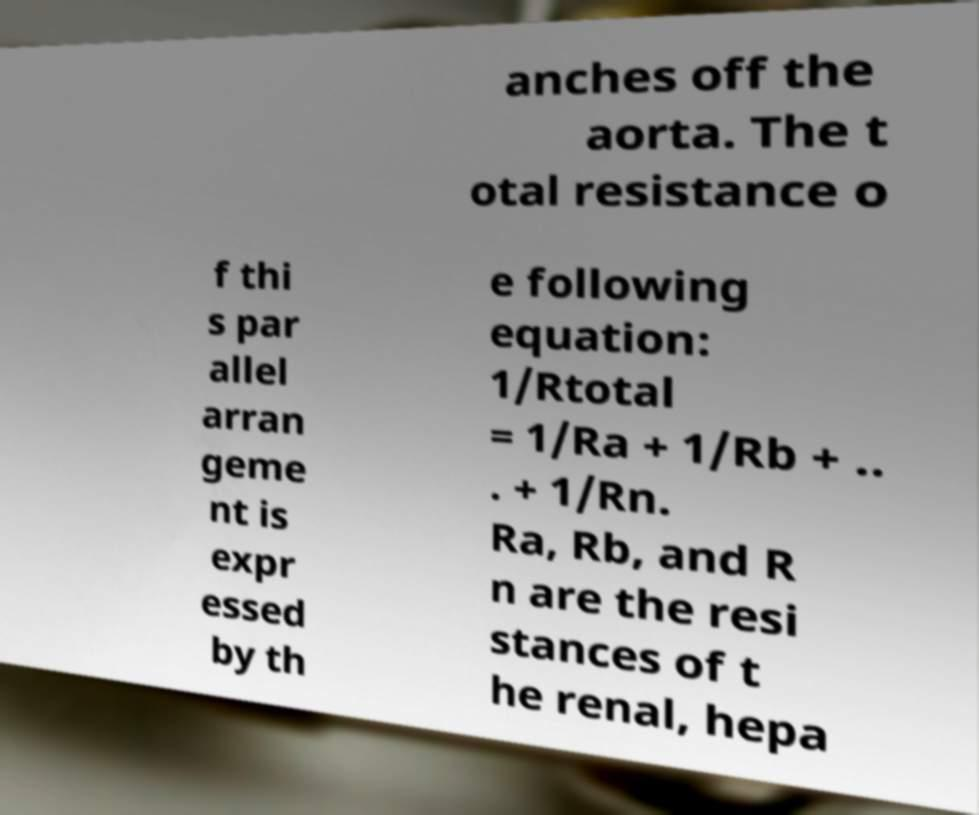Please identify and transcribe the text found in this image. anches off the aorta. The t otal resistance o f thi s par allel arran geme nt is expr essed by th e following equation: 1/Rtotal = 1/Ra + 1/Rb + .. . + 1/Rn. Ra, Rb, and R n are the resi stances of t he renal, hepa 